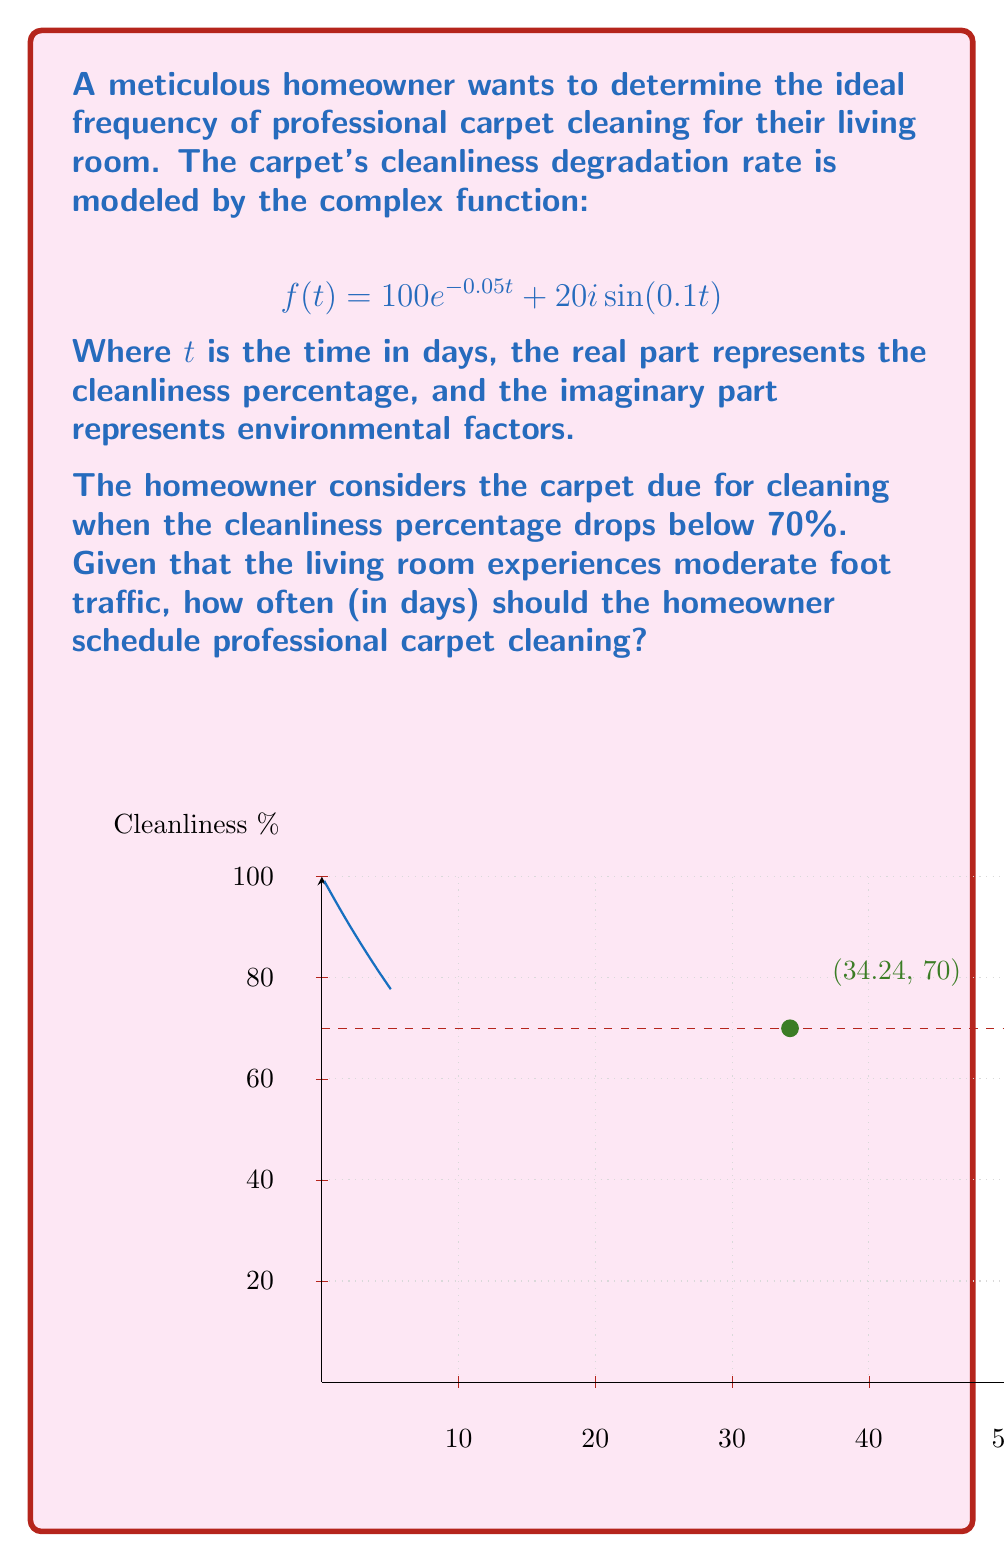Could you help me with this problem? To solve this problem, we need to follow these steps:

1) We're only concerned with the real part of the complex function, as it represents the cleanliness percentage. So we'll focus on:

   $$100e^{-0.05t}$$

2) We need to find when this function equals 70:

   $$100e^{-0.05t} = 70$$

3) Divide both sides by 100:

   $$e^{-0.05t} = 0.7$$

4) Take the natural logarithm of both sides:

   $$\ln(e^{-0.05t}) = \ln(0.7)$$
   $$-0.05t = \ln(0.7)$$

5) Divide both sides by -0.05:

   $$t = -\frac{\ln(0.7)}{0.05}$$

6) Calculate the value:

   $$t \approx 34.24$$

Therefore, the carpet's cleanliness drops to 70% after approximately 34.24 days.

7) Given moderate foot traffic, it's advisable to clean slightly before it reaches this point. Rounding down to the nearest whole number of days provides a good interval for scheduling.
Answer: 34 days 